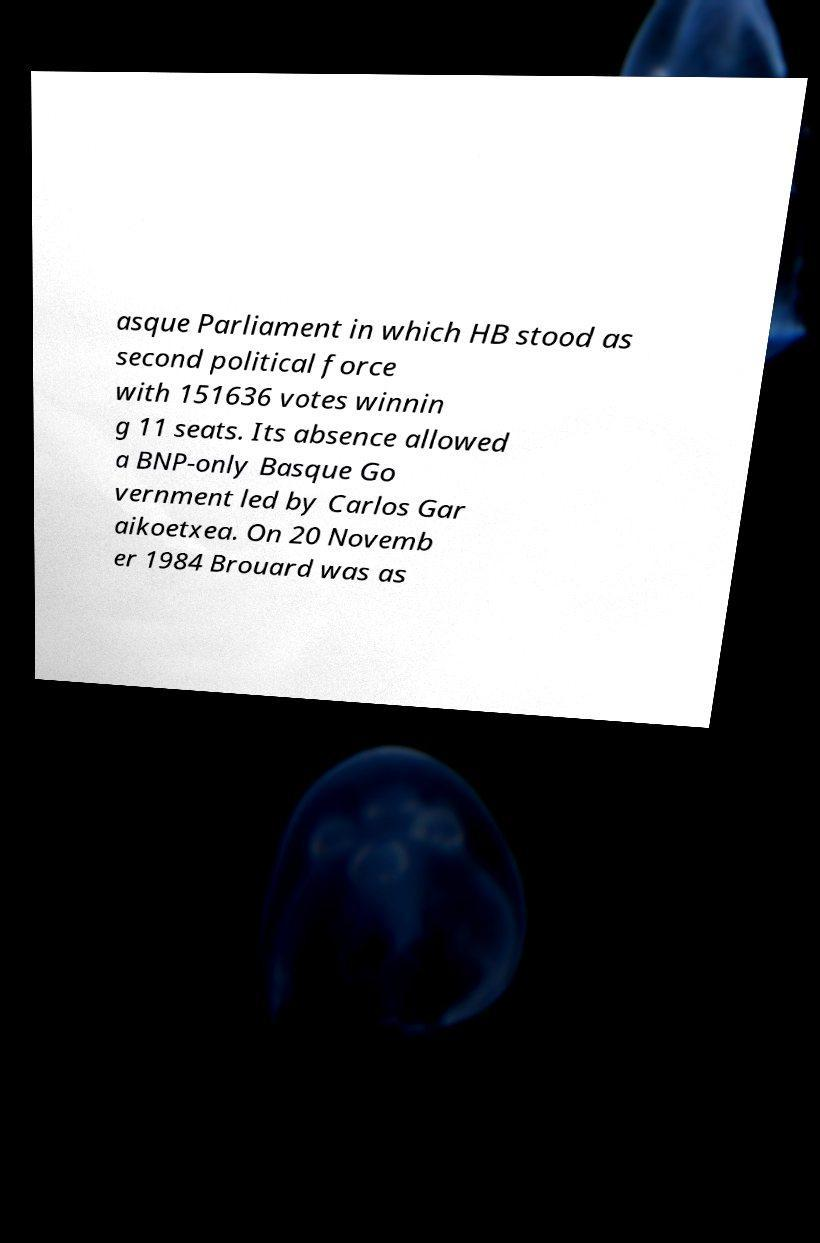Please identify and transcribe the text found in this image. asque Parliament in which HB stood as second political force with 151636 votes winnin g 11 seats. Its absence allowed a BNP-only Basque Go vernment led by Carlos Gar aikoetxea. On 20 Novemb er 1984 Brouard was as 